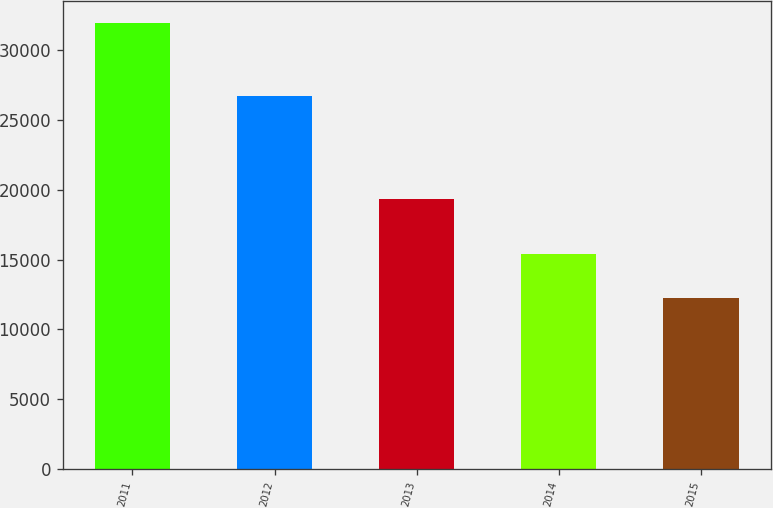Convert chart. <chart><loc_0><loc_0><loc_500><loc_500><bar_chart><fcel>2011<fcel>2012<fcel>2013<fcel>2014<fcel>2015<nl><fcel>31942<fcel>26727<fcel>19365<fcel>15391<fcel>12277<nl></chart> 